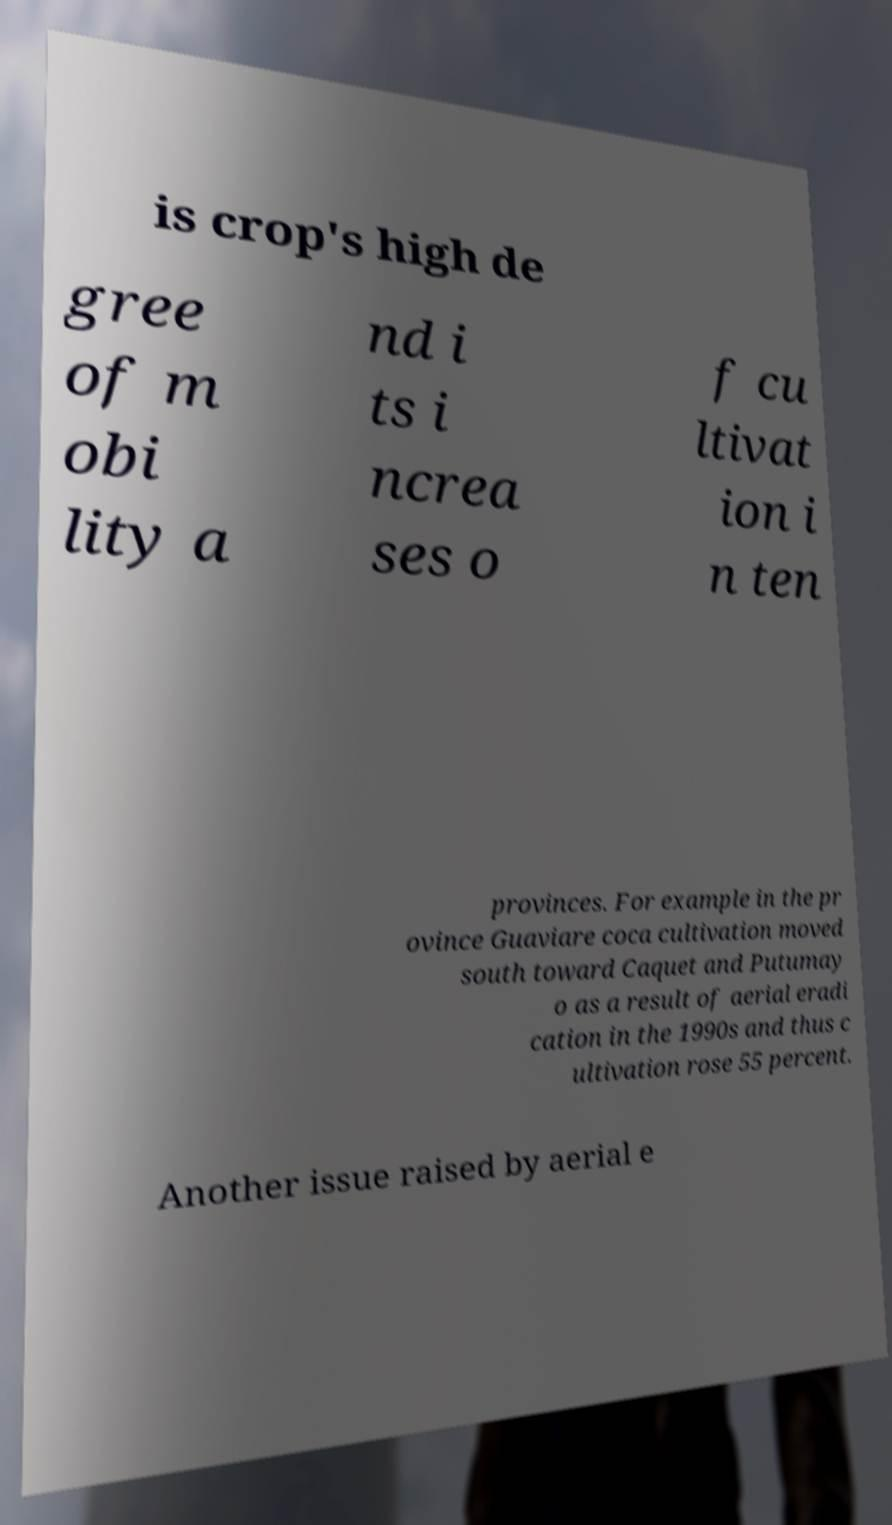Please read and relay the text visible in this image. What does it say? is crop's high de gree of m obi lity a nd i ts i ncrea ses o f cu ltivat ion i n ten provinces. For example in the pr ovince Guaviare coca cultivation moved south toward Caquet and Putumay o as a result of aerial eradi cation in the 1990s and thus c ultivation rose 55 percent. Another issue raised by aerial e 